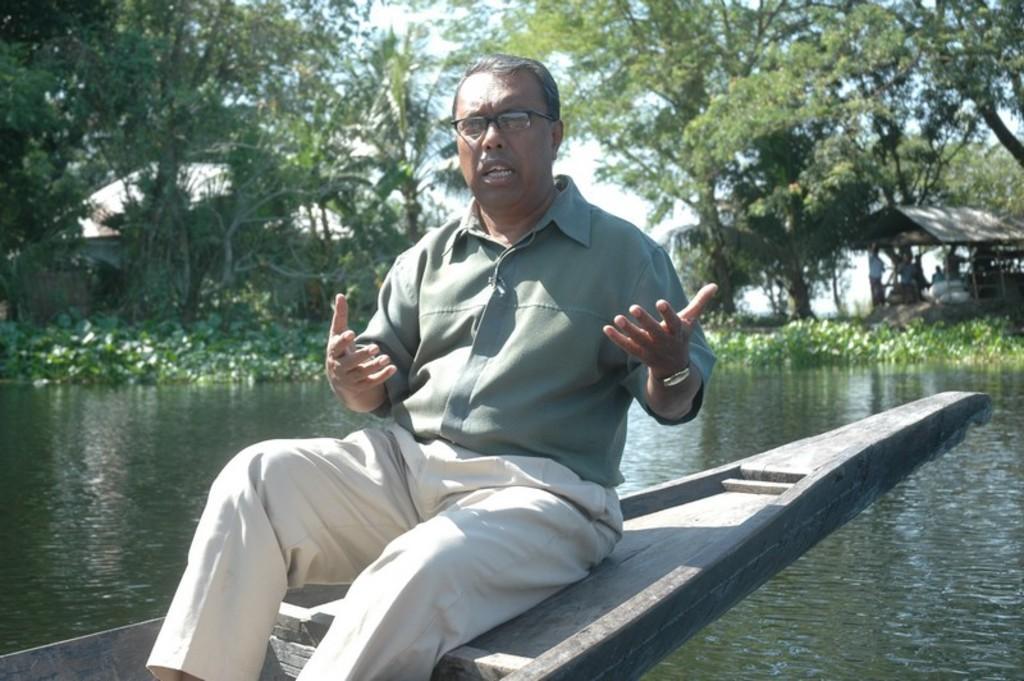Can you describe this image briefly? In this picture there is a man sitting on a boat and we can see water. In the background of the image there are people and we can see plants, shade, trees, sky and objects. 